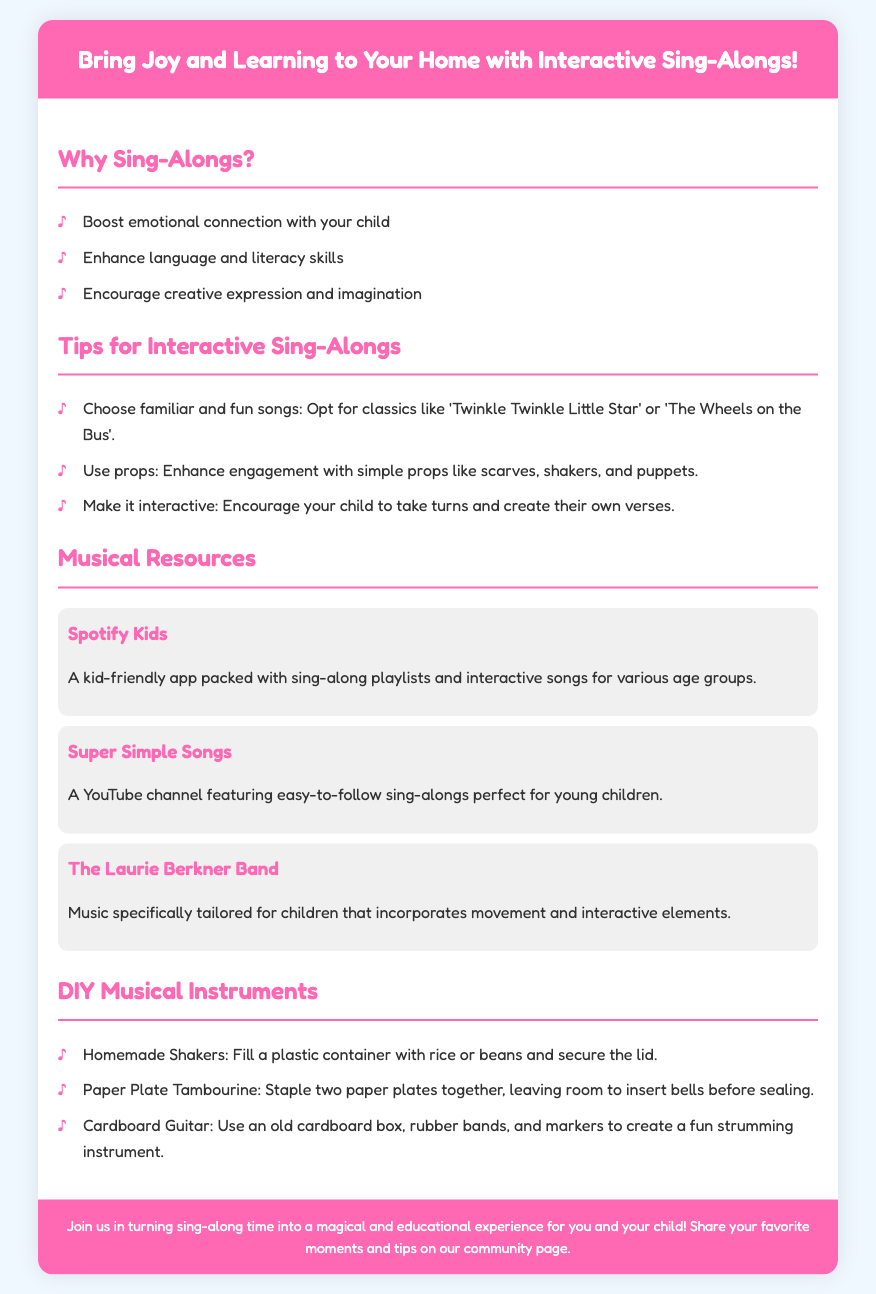What are the benefits of sing-alongs? The benefits include boosting emotional connection, enhancing language and literacy skills, and encouraging creative expression.
Answer: Emotional connection, language and literacy skills, creative expression What song is suggested for interactive sing-alongs? The suggested songs include recognizable classics like 'Twinkle Twinkle Little Star' or 'The Wheels on the Bus'.
Answer: 'Twinkle Twinkle Little Star' What is one musical resource mentioned in the document? The document lists several resources, one of which is Spotify Kids.
Answer: Spotify Kids How can homemade shakers be made? The document describes making shakers by filling a plastic container with rice or beans and securing the lid.
Answer: Rice or beans in a plastic container What color is the header's background? The header has a background color of #ff69b4, which is a shade of pink.
Answer: Pink What is a tip for making sing-alongs interactive? One tip encourages children to take turns and create their own verses.
Answer: Create their own verses How many types of DIY musical instruments are mentioned? The document mentions three DIY musical instruments that can be made.
Answer: Three What is the purpose of this flyer? The flyer aims to turn sing-along time into a fun and educational experience for parents and children.
Answer: Fun and educational experience 